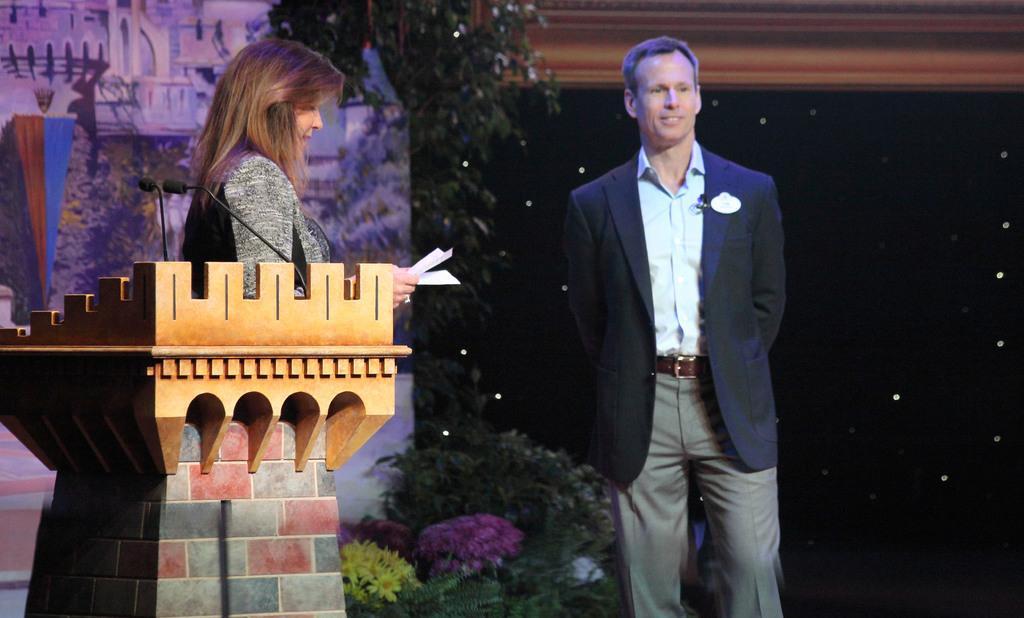Please provide a concise description of this image. In this image we can see a woman standing near a speaker stand holding some papers. We can also see a person standing beside her. On the backside we can see some plants and the wall. 